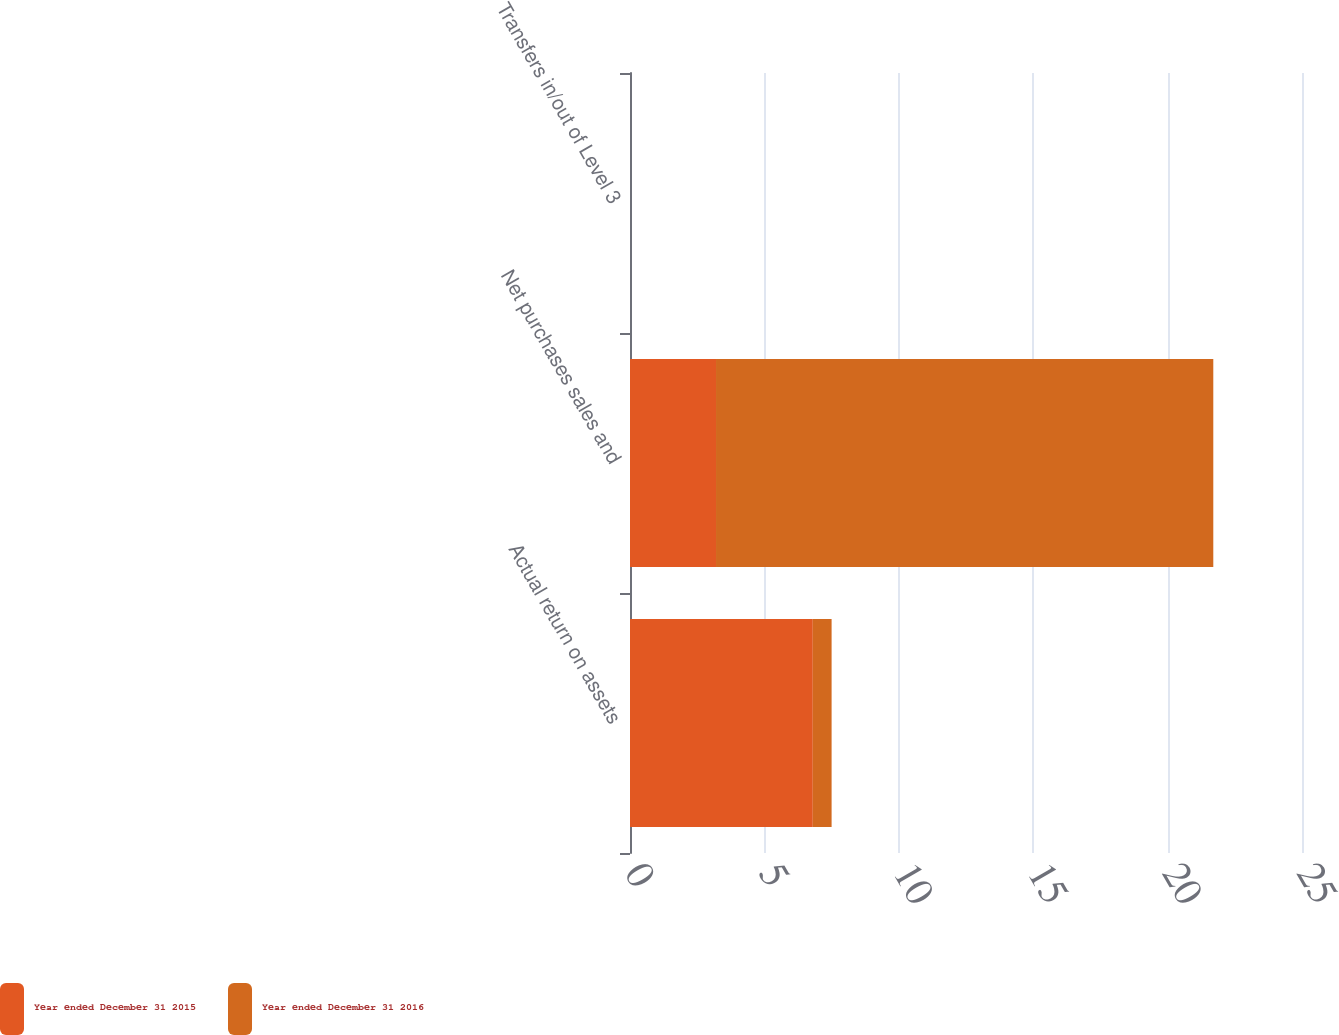Convert chart to OTSL. <chart><loc_0><loc_0><loc_500><loc_500><stacked_bar_chart><ecel><fcel>Actual return on assets<fcel>Net purchases sales and<fcel>Transfers in/out of Level 3<nl><fcel>Year ended December 31 2015<fcel>6.8<fcel>3.2<fcel>0<nl><fcel>Year ended December 31 2016<fcel>0.7<fcel>18.5<fcel>0<nl></chart> 